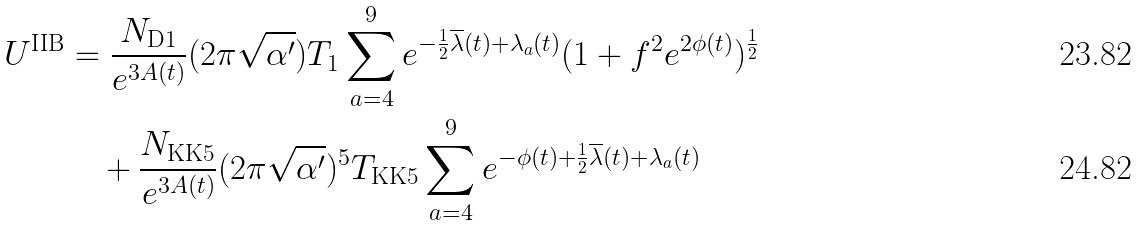<formula> <loc_0><loc_0><loc_500><loc_500>U ^ { \text {IIB} } & = \frac { N _ { \text {D1} } } { e ^ { 3 A ( t ) } } ( 2 \pi \sqrt { \alpha ^ { \prime } } ) T _ { \text {1} } \sum _ { a = 4 } ^ { 9 } e ^ { - \frac { 1 } { 2 } \overline { \lambda } ( t ) + \lambda _ { a } ( t ) } ( 1 + f ^ { 2 } e ^ { 2 \phi ( t ) } ) ^ { \frac { 1 } { 2 } } \\ & \quad + \frac { N _ { \text {KK5} } } { e ^ { 3 A ( t ) } } ( 2 \pi \sqrt { \alpha ^ { \prime } } ) ^ { 5 } T _ { \text {KK5} } \sum _ { a = 4 } ^ { 9 } e ^ { - \phi ( t ) + \frac { 1 } { 2 } \overline { \lambda } ( t ) + \lambda _ { a } ( t ) }</formula> 